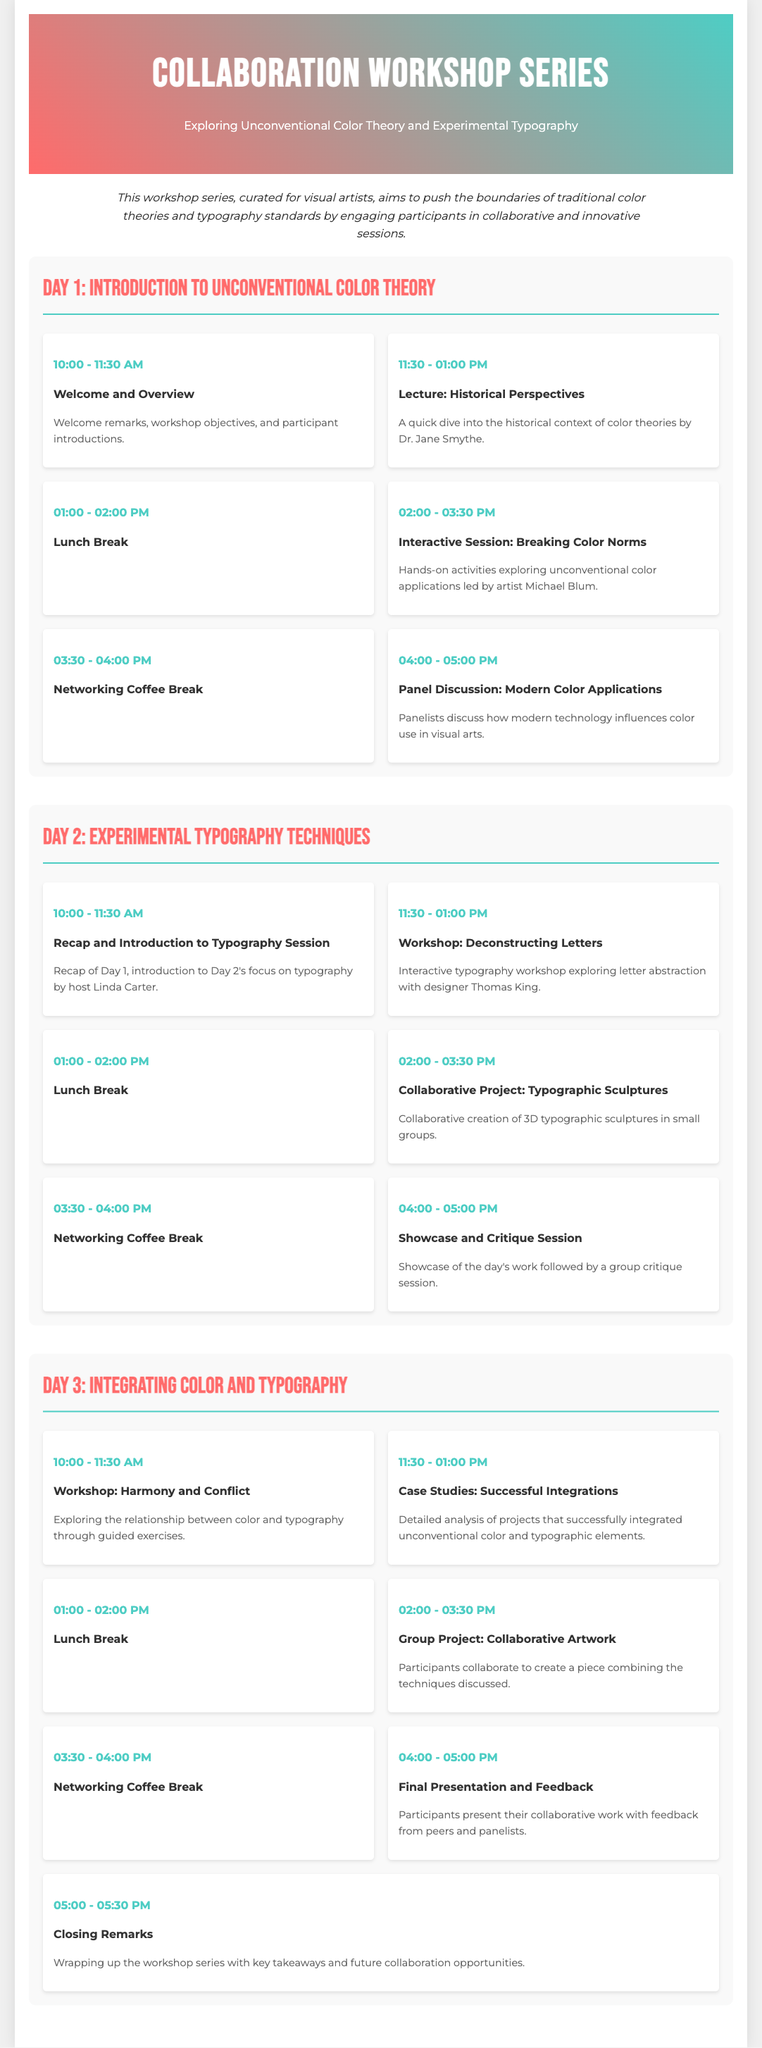What is the title of the workshop series? The title is prominently displayed at the top of the document.
Answer: Collaboration Workshop Series Who is hosting the Introduction to Unconventional Color Theory? The host is mentioned in the session details of Day 1.
Answer: Dr. Jane Smythe What time does the session on Deconstructing Letters start? This information is provided in the schedule for Day 2.
Answer: 11:30 AM How long is the lunch break on Day 3? The duration of the lunch breaks is consistent throughout the document, mentioned for each day.
Answer: 1 hour What activity follows the Networking Coffee Break on Day 2? The activities are listed in sequence in the schedule for Day 2.
Answer: Showcase and Critique Session Which day focuses on integrating color and typography? The title of the session indicates the central theme of the day.
Answer: Day 3 How many total days does the workshop series last? The structure of the document indicates the number of distinct sessions.
Answer: 3 days Who leads the interactive session on Day 1? The name of the artist facilitating the session is included in the schedule.
Answer: Michael Blum 